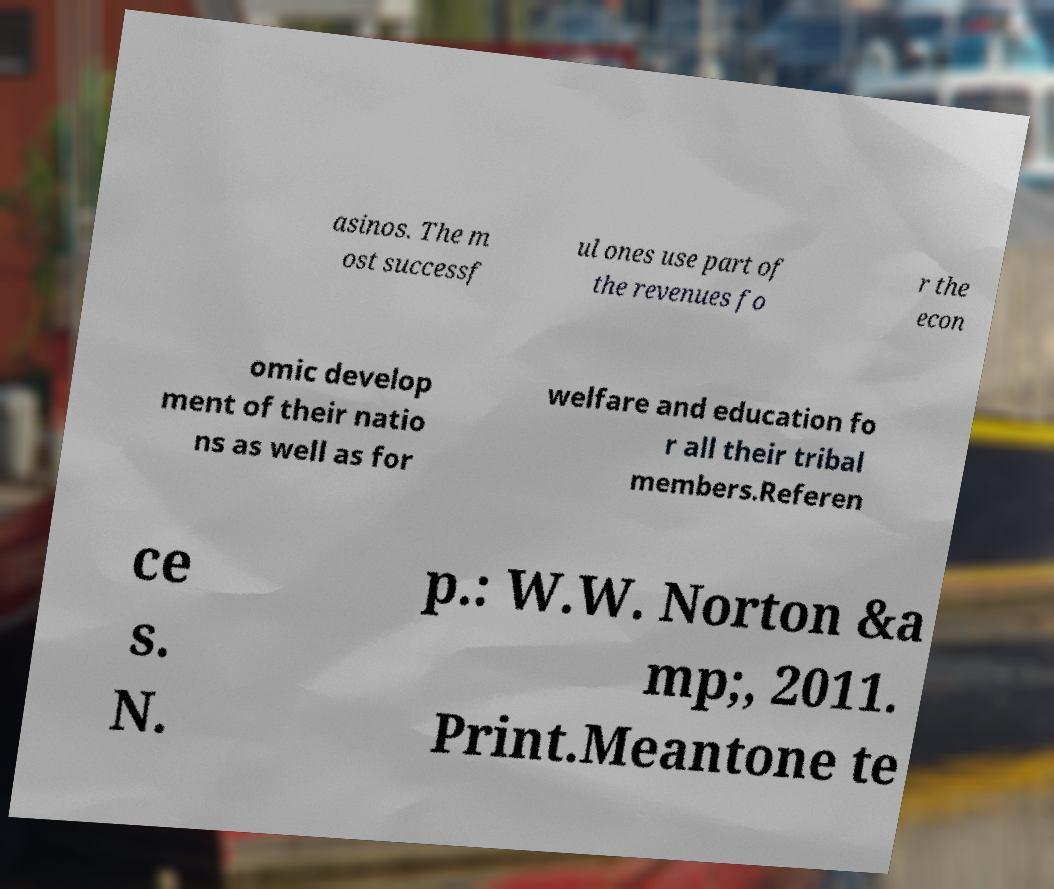What messages or text are displayed in this image? I need them in a readable, typed format. asinos. The m ost successf ul ones use part of the revenues fo r the econ omic develop ment of their natio ns as well as for welfare and education fo r all their tribal members.Referen ce s. N. p.: W.W. Norton &a mp;, 2011. Print.Meantone te 